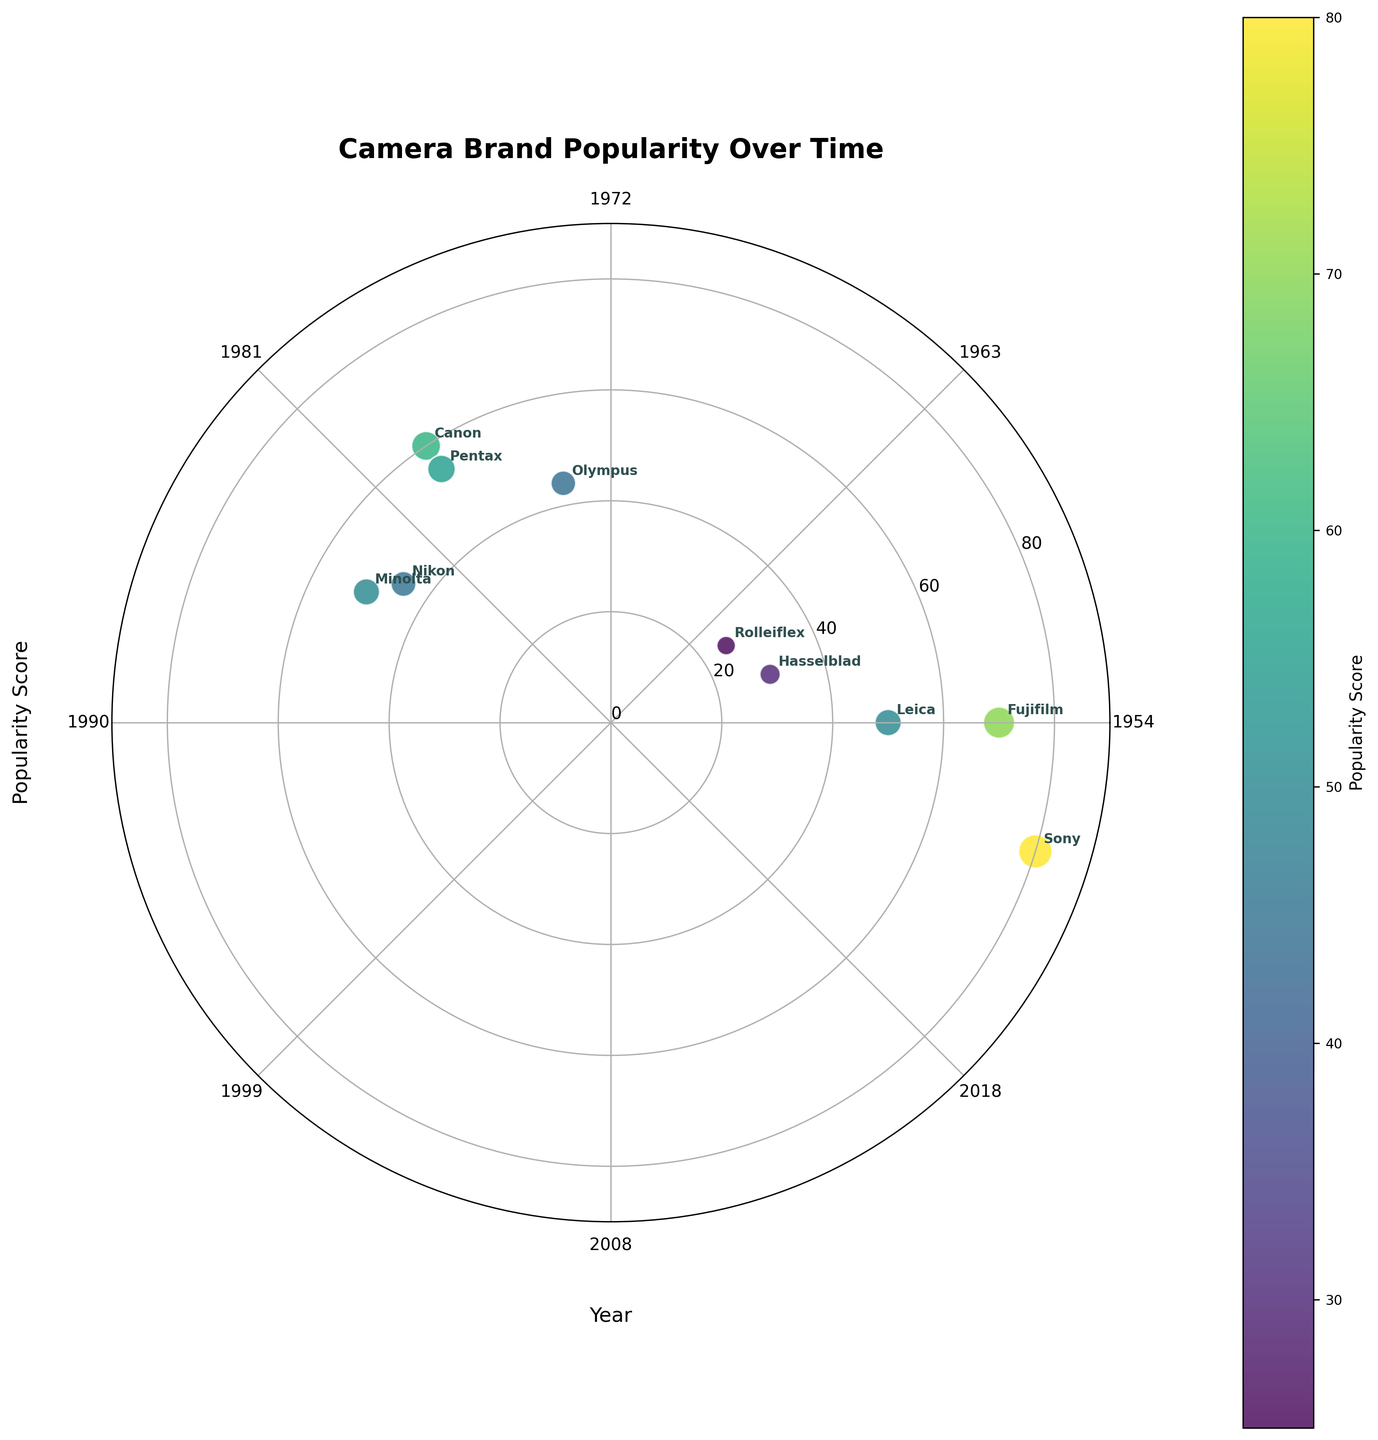What is the title of the figure? The title of the figure is displayed at the top of the plot. It provides a concise summary of what the plot represents.
Answer: Camera Brand Popularity Over Time How many data points are shown in the figure? Count the number of distinct scatter points plotted on the figure. Each point represents a camera model.
Answer: 10 Which camera model is represented by the most popular point? Identify the scatter point with the highest popularity score, and check the brand label annotated near it.
Answer: Sony A7R II Between which years do the camera models in the figure range? Look at the theta ticks on the polar chart representing the years and identify the minimum and maximum years.
Answer: 1954 to 2018 Which brand is closest in popularity to the Nikon FM2, and what is its popularity score? Find the scatter point for Nikon FM2, note its popularity score, and compare it to nearby points to find the closest match.
Answer: Minolta X-700 with a popularity score of 50 What is the approximate difference in popularity between the most and least popular camera models? Find the popularity scores of the most and least popular models and subtract the smallest score from the largest.
Answer: 80 - 25 = 55 Which two camera models released in 1976 are represented in the figure, and how do their popularity scores compare? Locate the points with theta positions corresponding to 1976 and check their brand labels and popularity scores.
Answer: Canon AE-1 (60) and Pentax K1000 (55); Canon AE-1 is more popular Is there a significant trend between the year of release and the popularity score? Observe if the scatter points form any noticeable pattern that correlates earlier or later years with higher/lower popularity scores.
Answer: No clear trend What is the average popularity score of all camera models in the figure? Sum all the popularity scores and divide by the number of camera models.
Answer: (45 + 60 + 50 + 30 + 55 + 80 + 70 + 44 + 25 + 50) / 10 = 50.9 Which decade has the most number of camera models represented, and how many models are there? Group the points based on their release decades and count the number of points in each period.
Answer: The 1970s with 4 models 